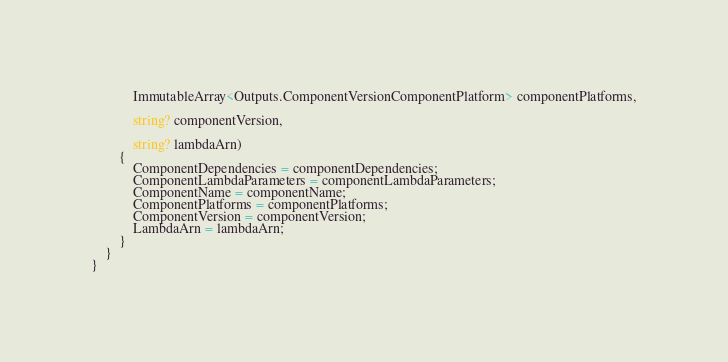<code> <loc_0><loc_0><loc_500><loc_500><_C#_>            ImmutableArray<Outputs.ComponentVersionComponentPlatform> componentPlatforms,

            string? componentVersion,

            string? lambdaArn)
        {
            ComponentDependencies = componentDependencies;
            ComponentLambdaParameters = componentLambdaParameters;
            ComponentName = componentName;
            ComponentPlatforms = componentPlatforms;
            ComponentVersion = componentVersion;
            LambdaArn = lambdaArn;
        }
    }
}
</code> 